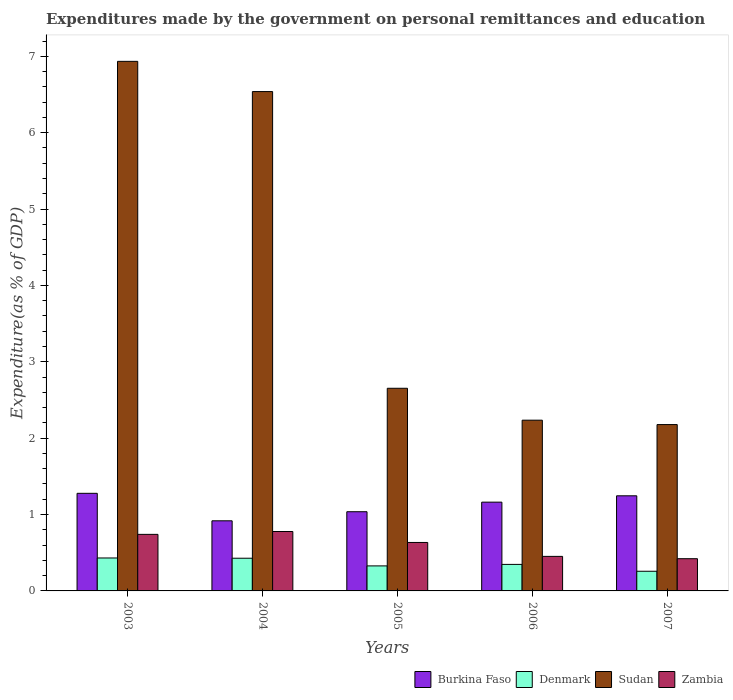How many groups of bars are there?
Your answer should be very brief. 5. What is the label of the 5th group of bars from the left?
Provide a succinct answer. 2007. In how many cases, is the number of bars for a given year not equal to the number of legend labels?
Provide a succinct answer. 0. What is the expenditures made by the government on personal remittances and education in Burkina Faso in 2005?
Give a very brief answer. 1.04. Across all years, what is the maximum expenditures made by the government on personal remittances and education in Zambia?
Ensure brevity in your answer.  0.78. Across all years, what is the minimum expenditures made by the government on personal remittances and education in Burkina Faso?
Your answer should be very brief. 0.92. What is the total expenditures made by the government on personal remittances and education in Denmark in the graph?
Your answer should be compact. 1.79. What is the difference between the expenditures made by the government on personal remittances and education in Burkina Faso in 2003 and that in 2006?
Provide a succinct answer. 0.12. What is the difference between the expenditures made by the government on personal remittances and education in Zambia in 2005 and the expenditures made by the government on personal remittances and education in Sudan in 2004?
Offer a terse response. -5.9. What is the average expenditures made by the government on personal remittances and education in Sudan per year?
Ensure brevity in your answer.  4.11. In the year 2007, what is the difference between the expenditures made by the government on personal remittances and education in Sudan and expenditures made by the government on personal remittances and education in Denmark?
Keep it short and to the point. 1.92. What is the ratio of the expenditures made by the government on personal remittances and education in Sudan in 2005 to that in 2006?
Offer a terse response. 1.19. Is the difference between the expenditures made by the government on personal remittances and education in Sudan in 2003 and 2006 greater than the difference between the expenditures made by the government on personal remittances and education in Denmark in 2003 and 2006?
Offer a very short reply. Yes. What is the difference between the highest and the second highest expenditures made by the government on personal remittances and education in Sudan?
Provide a succinct answer. 0.4. What is the difference between the highest and the lowest expenditures made by the government on personal remittances and education in Sudan?
Provide a succinct answer. 4.76. Is the sum of the expenditures made by the government on personal remittances and education in Sudan in 2005 and 2006 greater than the maximum expenditures made by the government on personal remittances and education in Zambia across all years?
Make the answer very short. Yes. What does the 3rd bar from the left in 2006 represents?
Offer a very short reply. Sudan. What does the 4th bar from the right in 2003 represents?
Offer a terse response. Burkina Faso. Is it the case that in every year, the sum of the expenditures made by the government on personal remittances and education in Denmark and expenditures made by the government on personal remittances and education in Sudan is greater than the expenditures made by the government on personal remittances and education in Zambia?
Offer a very short reply. Yes. Are all the bars in the graph horizontal?
Your answer should be compact. No. How many years are there in the graph?
Make the answer very short. 5. Are the values on the major ticks of Y-axis written in scientific E-notation?
Ensure brevity in your answer.  No. Where does the legend appear in the graph?
Your answer should be compact. Bottom right. How many legend labels are there?
Offer a terse response. 4. How are the legend labels stacked?
Ensure brevity in your answer.  Horizontal. What is the title of the graph?
Provide a succinct answer. Expenditures made by the government on personal remittances and education. What is the label or title of the Y-axis?
Offer a very short reply. Expenditure(as % of GDP). What is the Expenditure(as % of GDP) of Burkina Faso in 2003?
Your answer should be very brief. 1.28. What is the Expenditure(as % of GDP) of Denmark in 2003?
Ensure brevity in your answer.  0.43. What is the Expenditure(as % of GDP) of Sudan in 2003?
Give a very brief answer. 6.93. What is the Expenditure(as % of GDP) in Zambia in 2003?
Make the answer very short. 0.74. What is the Expenditure(as % of GDP) in Burkina Faso in 2004?
Offer a terse response. 0.92. What is the Expenditure(as % of GDP) of Denmark in 2004?
Keep it short and to the point. 0.43. What is the Expenditure(as % of GDP) in Sudan in 2004?
Provide a short and direct response. 6.54. What is the Expenditure(as % of GDP) in Zambia in 2004?
Offer a very short reply. 0.78. What is the Expenditure(as % of GDP) of Burkina Faso in 2005?
Provide a succinct answer. 1.04. What is the Expenditure(as % of GDP) in Denmark in 2005?
Give a very brief answer. 0.33. What is the Expenditure(as % of GDP) of Sudan in 2005?
Your answer should be very brief. 2.65. What is the Expenditure(as % of GDP) of Zambia in 2005?
Give a very brief answer. 0.63. What is the Expenditure(as % of GDP) in Burkina Faso in 2006?
Offer a very short reply. 1.16. What is the Expenditure(as % of GDP) in Denmark in 2006?
Your answer should be very brief. 0.35. What is the Expenditure(as % of GDP) in Sudan in 2006?
Your answer should be compact. 2.24. What is the Expenditure(as % of GDP) in Zambia in 2006?
Provide a succinct answer. 0.45. What is the Expenditure(as % of GDP) of Burkina Faso in 2007?
Your response must be concise. 1.25. What is the Expenditure(as % of GDP) in Denmark in 2007?
Offer a terse response. 0.26. What is the Expenditure(as % of GDP) in Sudan in 2007?
Give a very brief answer. 2.18. What is the Expenditure(as % of GDP) of Zambia in 2007?
Keep it short and to the point. 0.42. Across all years, what is the maximum Expenditure(as % of GDP) in Burkina Faso?
Give a very brief answer. 1.28. Across all years, what is the maximum Expenditure(as % of GDP) in Denmark?
Provide a short and direct response. 0.43. Across all years, what is the maximum Expenditure(as % of GDP) of Sudan?
Your answer should be very brief. 6.93. Across all years, what is the maximum Expenditure(as % of GDP) of Zambia?
Your response must be concise. 0.78. Across all years, what is the minimum Expenditure(as % of GDP) in Burkina Faso?
Ensure brevity in your answer.  0.92. Across all years, what is the minimum Expenditure(as % of GDP) in Denmark?
Offer a terse response. 0.26. Across all years, what is the minimum Expenditure(as % of GDP) in Sudan?
Offer a terse response. 2.18. Across all years, what is the minimum Expenditure(as % of GDP) in Zambia?
Your response must be concise. 0.42. What is the total Expenditure(as % of GDP) of Burkina Faso in the graph?
Provide a short and direct response. 5.64. What is the total Expenditure(as % of GDP) in Denmark in the graph?
Give a very brief answer. 1.79. What is the total Expenditure(as % of GDP) of Sudan in the graph?
Make the answer very short. 20.54. What is the total Expenditure(as % of GDP) of Zambia in the graph?
Make the answer very short. 3.03. What is the difference between the Expenditure(as % of GDP) in Burkina Faso in 2003 and that in 2004?
Offer a terse response. 0.36. What is the difference between the Expenditure(as % of GDP) of Denmark in 2003 and that in 2004?
Provide a succinct answer. 0. What is the difference between the Expenditure(as % of GDP) in Sudan in 2003 and that in 2004?
Ensure brevity in your answer.  0.4. What is the difference between the Expenditure(as % of GDP) of Zambia in 2003 and that in 2004?
Your response must be concise. -0.04. What is the difference between the Expenditure(as % of GDP) of Burkina Faso in 2003 and that in 2005?
Offer a very short reply. 0.24. What is the difference between the Expenditure(as % of GDP) of Denmark in 2003 and that in 2005?
Ensure brevity in your answer.  0.1. What is the difference between the Expenditure(as % of GDP) of Sudan in 2003 and that in 2005?
Your response must be concise. 4.28. What is the difference between the Expenditure(as % of GDP) in Zambia in 2003 and that in 2005?
Make the answer very short. 0.11. What is the difference between the Expenditure(as % of GDP) of Burkina Faso in 2003 and that in 2006?
Give a very brief answer. 0.12. What is the difference between the Expenditure(as % of GDP) in Denmark in 2003 and that in 2006?
Your response must be concise. 0.08. What is the difference between the Expenditure(as % of GDP) of Sudan in 2003 and that in 2006?
Your response must be concise. 4.7. What is the difference between the Expenditure(as % of GDP) of Zambia in 2003 and that in 2006?
Provide a short and direct response. 0.29. What is the difference between the Expenditure(as % of GDP) of Burkina Faso in 2003 and that in 2007?
Your answer should be very brief. 0.03. What is the difference between the Expenditure(as % of GDP) in Denmark in 2003 and that in 2007?
Offer a very short reply. 0.17. What is the difference between the Expenditure(as % of GDP) in Sudan in 2003 and that in 2007?
Your answer should be very brief. 4.76. What is the difference between the Expenditure(as % of GDP) in Zambia in 2003 and that in 2007?
Provide a short and direct response. 0.32. What is the difference between the Expenditure(as % of GDP) in Burkina Faso in 2004 and that in 2005?
Ensure brevity in your answer.  -0.12. What is the difference between the Expenditure(as % of GDP) in Denmark in 2004 and that in 2005?
Provide a short and direct response. 0.1. What is the difference between the Expenditure(as % of GDP) of Sudan in 2004 and that in 2005?
Your answer should be compact. 3.88. What is the difference between the Expenditure(as % of GDP) of Zambia in 2004 and that in 2005?
Provide a succinct answer. 0.14. What is the difference between the Expenditure(as % of GDP) in Burkina Faso in 2004 and that in 2006?
Your response must be concise. -0.24. What is the difference between the Expenditure(as % of GDP) of Denmark in 2004 and that in 2006?
Your answer should be compact. 0.08. What is the difference between the Expenditure(as % of GDP) in Sudan in 2004 and that in 2006?
Keep it short and to the point. 4.3. What is the difference between the Expenditure(as % of GDP) in Zambia in 2004 and that in 2006?
Your answer should be compact. 0.33. What is the difference between the Expenditure(as % of GDP) of Burkina Faso in 2004 and that in 2007?
Offer a terse response. -0.33. What is the difference between the Expenditure(as % of GDP) in Denmark in 2004 and that in 2007?
Your answer should be very brief. 0.17. What is the difference between the Expenditure(as % of GDP) in Sudan in 2004 and that in 2007?
Offer a terse response. 4.36. What is the difference between the Expenditure(as % of GDP) of Zambia in 2004 and that in 2007?
Give a very brief answer. 0.36. What is the difference between the Expenditure(as % of GDP) of Burkina Faso in 2005 and that in 2006?
Your answer should be compact. -0.13. What is the difference between the Expenditure(as % of GDP) in Denmark in 2005 and that in 2006?
Offer a very short reply. -0.02. What is the difference between the Expenditure(as % of GDP) of Sudan in 2005 and that in 2006?
Give a very brief answer. 0.42. What is the difference between the Expenditure(as % of GDP) of Zambia in 2005 and that in 2006?
Offer a terse response. 0.18. What is the difference between the Expenditure(as % of GDP) of Burkina Faso in 2005 and that in 2007?
Offer a very short reply. -0.21. What is the difference between the Expenditure(as % of GDP) of Denmark in 2005 and that in 2007?
Your answer should be very brief. 0.07. What is the difference between the Expenditure(as % of GDP) in Sudan in 2005 and that in 2007?
Your answer should be very brief. 0.48. What is the difference between the Expenditure(as % of GDP) of Zambia in 2005 and that in 2007?
Provide a succinct answer. 0.21. What is the difference between the Expenditure(as % of GDP) in Burkina Faso in 2006 and that in 2007?
Your response must be concise. -0.08. What is the difference between the Expenditure(as % of GDP) of Denmark in 2006 and that in 2007?
Give a very brief answer. 0.09. What is the difference between the Expenditure(as % of GDP) of Sudan in 2006 and that in 2007?
Offer a very short reply. 0.06. What is the difference between the Expenditure(as % of GDP) of Zambia in 2006 and that in 2007?
Ensure brevity in your answer.  0.03. What is the difference between the Expenditure(as % of GDP) of Burkina Faso in 2003 and the Expenditure(as % of GDP) of Denmark in 2004?
Offer a very short reply. 0.85. What is the difference between the Expenditure(as % of GDP) of Burkina Faso in 2003 and the Expenditure(as % of GDP) of Sudan in 2004?
Provide a succinct answer. -5.26. What is the difference between the Expenditure(as % of GDP) in Denmark in 2003 and the Expenditure(as % of GDP) in Sudan in 2004?
Make the answer very short. -6.11. What is the difference between the Expenditure(as % of GDP) in Denmark in 2003 and the Expenditure(as % of GDP) in Zambia in 2004?
Give a very brief answer. -0.35. What is the difference between the Expenditure(as % of GDP) of Sudan in 2003 and the Expenditure(as % of GDP) of Zambia in 2004?
Give a very brief answer. 6.16. What is the difference between the Expenditure(as % of GDP) in Burkina Faso in 2003 and the Expenditure(as % of GDP) in Denmark in 2005?
Your answer should be very brief. 0.95. What is the difference between the Expenditure(as % of GDP) of Burkina Faso in 2003 and the Expenditure(as % of GDP) of Sudan in 2005?
Your response must be concise. -1.38. What is the difference between the Expenditure(as % of GDP) of Burkina Faso in 2003 and the Expenditure(as % of GDP) of Zambia in 2005?
Your answer should be very brief. 0.64. What is the difference between the Expenditure(as % of GDP) in Denmark in 2003 and the Expenditure(as % of GDP) in Sudan in 2005?
Make the answer very short. -2.22. What is the difference between the Expenditure(as % of GDP) of Denmark in 2003 and the Expenditure(as % of GDP) of Zambia in 2005?
Provide a succinct answer. -0.2. What is the difference between the Expenditure(as % of GDP) of Sudan in 2003 and the Expenditure(as % of GDP) of Zambia in 2005?
Your response must be concise. 6.3. What is the difference between the Expenditure(as % of GDP) of Burkina Faso in 2003 and the Expenditure(as % of GDP) of Denmark in 2006?
Offer a terse response. 0.93. What is the difference between the Expenditure(as % of GDP) in Burkina Faso in 2003 and the Expenditure(as % of GDP) in Sudan in 2006?
Give a very brief answer. -0.96. What is the difference between the Expenditure(as % of GDP) of Burkina Faso in 2003 and the Expenditure(as % of GDP) of Zambia in 2006?
Make the answer very short. 0.83. What is the difference between the Expenditure(as % of GDP) of Denmark in 2003 and the Expenditure(as % of GDP) of Sudan in 2006?
Provide a succinct answer. -1.8. What is the difference between the Expenditure(as % of GDP) in Denmark in 2003 and the Expenditure(as % of GDP) in Zambia in 2006?
Make the answer very short. -0.02. What is the difference between the Expenditure(as % of GDP) in Sudan in 2003 and the Expenditure(as % of GDP) in Zambia in 2006?
Keep it short and to the point. 6.48. What is the difference between the Expenditure(as % of GDP) in Burkina Faso in 2003 and the Expenditure(as % of GDP) in Denmark in 2007?
Ensure brevity in your answer.  1.02. What is the difference between the Expenditure(as % of GDP) of Burkina Faso in 2003 and the Expenditure(as % of GDP) of Sudan in 2007?
Provide a succinct answer. -0.9. What is the difference between the Expenditure(as % of GDP) of Burkina Faso in 2003 and the Expenditure(as % of GDP) of Zambia in 2007?
Offer a very short reply. 0.86. What is the difference between the Expenditure(as % of GDP) in Denmark in 2003 and the Expenditure(as % of GDP) in Sudan in 2007?
Provide a succinct answer. -1.75. What is the difference between the Expenditure(as % of GDP) in Denmark in 2003 and the Expenditure(as % of GDP) in Zambia in 2007?
Offer a very short reply. 0.01. What is the difference between the Expenditure(as % of GDP) of Sudan in 2003 and the Expenditure(as % of GDP) of Zambia in 2007?
Give a very brief answer. 6.51. What is the difference between the Expenditure(as % of GDP) of Burkina Faso in 2004 and the Expenditure(as % of GDP) of Denmark in 2005?
Make the answer very short. 0.59. What is the difference between the Expenditure(as % of GDP) of Burkina Faso in 2004 and the Expenditure(as % of GDP) of Sudan in 2005?
Your answer should be compact. -1.74. What is the difference between the Expenditure(as % of GDP) of Burkina Faso in 2004 and the Expenditure(as % of GDP) of Zambia in 2005?
Make the answer very short. 0.28. What is the difference between the Expenditure(as % of GDP) of Denmark in 2004 and the Expenditure(as % of GDP) of Sudan in 2005?
Provide a succinct answer. -2.23. What is the difference between the Expenditure(as % of GDP) in Denmark in 2004 and the Expenditure(as % of GDP) in Zambia in 2005?
Give a very brief answer. -0.21. What is the difference between the Expenditure(as % of GDP) of Sudan in 2004 and the Expenditure(as % of GDP) of Zambia in 2005?
Offer a very short reply. 5.9. What is the difference between the Expenditure(as % of GDP) of Burkina Faso in 2004 and the Expenditure(as % of GDP) of Denmark in 2006?
Ensure brevity in your answer.  0.57. What is the difference between the Expenditure(as % of GDP) in Burkina Faso in 2004 and the Expenditure(as % of GDP) in Sudan in 2006?
Your answer should be very brief. -1.32. What is the difference between the Expenditure(as % of GDP) in Burkina Faso in 2004 and the Expenditure(as % of GDP) in Zambia in 2006?
Ensure brevity in your answer.  0.47. What is the difference between the Expenditure(as % of GDP) of Denmark in 2004 and the Expenditure(as % of GDP) of Sudan in 2006?
Your answer should be very brief. -1.81. What is the difference between the Expenditure(as % of GDP) of Denmark in 2004 and the Expenditure(as % of GDP) of Zambia in 2006?
Your answer should be very brief. -0.02. What is the difference between the Expenditure(as % of GDP) of Sudan in 2004 and the Expenditure(as % of GDP) of Zambia in 2006?
Your answer should be very brief. 6.09. What is the difference between the Expenditure(as % of GDP) of Burkina Faso in 2004 and the Expenditure(as % of GDP) of Denmark in 2007?
Give a very brief answer. 0.66. What is the difference between the Expenditure(as % of GDP) in Burkina Faso in 2004 and the Expenditure(as % of GDP) in Sudan in 2007?
Offer a very short reply. -1.26. What is the difference between the Expenditure(as % of GDP) in Burkina Faso in 2004 and the Expenditure(as % of GDP) in Zambia in 2007?
Keep it short and to the point. 0.5. What is the difference between the Expenditure(as % of GDP) in Denmark in 2004 and the Expenditure(as % of GDP) in Sudan in 2007?
Make the answer very short. -1.75. What is the difference between the Expenditure(as % of GDP) in Denmark in 2004 and the Expenditure(as % of GDP) in Zambia in 2007?
Make the answer very short. 0.01. What is the difference between the Expenditure(as % of GDP) in Sudan in 2004 and the Expenditure(as % of GDP) in Zambia in 2007?
Your answer should be compact. 6.12. What is the difference between the Expenditure(as % of GDP) in Burkina Faso in 2005 and the Expenditure(as % of GDP) in Denmark in 2006?
Offer a terse response. 0.69. What is the difference between the Expenditure(as % of GDP) in Burkina Faso in 2005 and the Expenditure(as % of GDP) in Sudan in 2006?
Offer a very short reply. -1.2. What is the difference between the Expenditure(as % of GDP) of Burkina Faso in 2005 and the Expenditure(as % of GDP) of Zambia in 2006?
Your answer should be very brief. 0.58. What is the difference between the Expenditure(as % of GDP) in Denmark in 2005 and the Expenditure(as % of GDP) in Sudan in 2006?
Your answer should be very brief. -1.91. What is the difference between the Expenditure(as % of GDP) of Denmark in 2005 and the Expenditure(as % of GDP) of Zambia in 2006?
Give a very brief answer. -0.12. What is the difference between the Expenditure(as % of GDP) of Sudan in 2005 and the Expenditure(as % of GDP) of Zambia in 2006?
Your response must be concise. 2.2. What is the difference between the Expenditure(as % of GDP) in Burkina Faso in 2005 and the Expenditure(as % of GDP) in Denmark in 2007?
Offer a very short reply. 0.78. What is the difference between the Expenditure(as % of GDP) in Burkina Faso in 2005 and the Expenditure(as % of GDP) in Sudan in 2007?
Offer a terse response. -1.14. What is the difference between the Expenditure(as % of GDP) in Burkina Faso in 2005 and the Expenditure(as % of GDP) in Zambia in 2007?
Your answer should be very brief. 0.61. What is the difference between the Expenditure(as % of GDP) of Denmark in 2005 and the Expenditure(as % of GDP) of Sudan in 2007?
Provide a succinct answer. -1.85. What is the difference between the Expenditure(as % of GDP) of Denmark in 2005 and the Expenditure(as % of GDP) of Zambia in 2007?
Your answer should be compact. -0.09. What is the difference between the Expenditure(as % of GDP) of Sudan in 2005 and the Expenditure(as % of GDP) of Zambia in 2007?
Make the answer very short. 2.23. What is the difference between the Expenditure(as % of GDP) of Burkina Faso in 2006 and the Expenditure(as % of GDP) of Denmark in 2007?
Keep it short and to the point. 0.9. What is the difference between the Expenditure(as % of GDP) in Burkina Faso in 2006 and the Expenditure(as % of GDP) in Sudan in 2007?
Your answer should be very brief. -1.02. What is the difference between the Expenditure(as % of GDP) in Burkina Faso in 2006 and the Expenditure(as % of GDP) in Zambia in 2007?
Keep it short and to the point. 0.74. What is the difference between the Expenditure(as % of GDP) in Denmark in 2006 and the Expenditure(as % of GDP) in Sudan in 2007?
Make the answer very short. -1.83. What is the difference between the Expenditure(as % of GDP) in Denmark in 2006 and the Expenditure(as % of GDP) in Zambia in 2007?
Your response must be concise. -0.07. What is the difference between the Expenditure(as % of GDP) of Sudan in 2006 and the Expenditure(as % of GDP) of Zambia in 2007?
Provide a succinct answer. 1.81. What is the average Expenditure(as % of GDP) in Burkina Faso per year?
Your response must be concise. 1.13. What is the average Expenditure(as % of GDP) of Denmark per year?
Give a very brief answer. 0.36. What is the average Expenditure(as % of GDP) of Sudan per year?
Offer a terse response. 4.11. What is the average Expenditure(as % of GDP) in Zambia per year?
Your response must be concise. 0.61. In the year 2003, what is the difference between the Expenditure(as % of GDP) in Burkina Faso and Expenditure(as % of GDP) in Denmark?
Offer a terse response. 0.85. In the year 2003, what is the difference between the Expenditure(as % of GDP) in Burkina Faso and Expenditure(as % of GDP) in Sudan?
Provide a short and direct response. -5.66. In the year 2003, what is the difference between the Expenditure(as % of GDP) in Burkina Faso and Expenditure(as % of GDP) in Zambia?
Offer a terse response. 0.54. In the year 2003, what is the difference between the Expenditure(as % of GDP) of Denmark and Expenditure(as % of GDP) of Sudan?
Provide a succinct answer. -6.5. In the year 2003, what is the difference between the Expenditure(as % of GDP) in Denmark and Expenditure(as % of GDP) in Zambia?
Ensure brevity in your answer.  -0.31. In the year 2003, what is the difference between the Expenditure(as % of GDP) in Sudan and Expenditure(as % of GDP) in Zambia?
Your response must be concise. 6.19. In the year 2004, what is the difference between the Expenditure(as % of GDP) in Burkina Faso and Expenditure(as % of GDP) in Denmark?
Your response must be concise. 0.49. In the year 2004, what is the difference between the Expenditure(as % of GDP) of Burkina Faso and Expenditure(as % of GDP) of Sudan?
Your answer should be very brief. -5.62. In the year 2004, what is the difference between the Expenditure(as % of GDP) in Burkina Faso and Expenditure(as % of GDP) in Zambia?
Make the answer very short. 0.14. In the year 2004, what is the difference between the Expenditure(as % of GDP) in Denmark and Expenditure(as % of GDP) in Sudan?
Your answer should be very brief. -6.11. In the year 2004, what is the difference between the Expenditure(as % of GDP) in Denmark and Expenditure(as % of GDP) in Zambia?
Offer a very short reply. -0.35. In the year 2004, what is the difference between the Expenditure(as % of GDP) of Sudan and Expenditure(as % of GDP) of Zambia?
Your answer should be compact. 5.76. In the year 2005, what is the difference between the Expenditure(as % of GDP) in Burkina Faso and Expenditure(as % of GDP) in Denmark?
Ensure brevity in your answer.  0.71. In the year 2005, what is the difference between the Expenditure(as % of GDP) of Burkina Faso and Expenditure(as % of GDP) of Sudan?
Your response must be concise. -1.62. In the year 2005, what is the difference between the Expenditure(as % of GDP) in Burkina Faso and Expenditure(as % of GDP) in Zambia?
Offer a terse response. 0.4. In the year 2005, what is the difference between the Expenditure(as % of GDP) of Denmark and Expenditure(as % of GDP) of Sudan?
Your response must be concise. -2.33. In the year 2005, what is the difference between the Expenditure(as % of GDP) in Denmark and Expenditure(as % of GDP) in Zambia?
Offer a very short reply. -0.31. In the year 2005, what is the difference between the Expenditure(as % of GDP) of Sudan and Expenditure(as % of GDP) of Zambia?
Keep it short and to the point. 2.02. In the year 2006, what is the difference between the Expenditure(as % of GDP) in Burkina Faso and Expenditure(as % of GDP) in Denmark?
Ensure brevity in your answer.  0.82. In the year 2006, what is the difference between the Expenditure(as % of GDP) of Burkina Faso and Expenditure(as % of GDP) of Sudan?
Offer a terse response. -1.07. In the year 2006, what is the difference between the Expenditure(as % of GDP) in Burkina Faso and Expenditure(as % of GDP) in Zambia?
Give a very brief answer. 0.71. In the year 2006, what is the difference between the Expenditure(as % of GDP) in Denmark and Expenditure(as % of GDP) in Sudan?
Keep it short and to the point. -1.89. In the year 2006, what is the difference between the Expenditure(as % of GDP) in Denmark and Expenditure(as % of GDP) in Zambia?
Offer a very short reply. -0.1. In the year 2006, what is the difference between the Expenditure(as % of GDP) of Sudan and Expenditure(as % of GDP) of Zambia?
Your answer should be compact. 1.78. In the year 2007, what is the difference between the Expenditure(as % of GDP) of Burkina Faso and Expenditure(as % of GDP) of Sudan?
Your answer should be compact. -0.93. In the year 2007, what is the difference between the Expenditure(as % of GDP) in Burkina Faso and Expenditure(as % of GDP) in Zambia?
Keep it short and to the point. 0.82. In the year 2007, what is the difference between the Expenditure(as % of GDP) in Denmark and Expenditure(as % of GDP) in Sudan?
Make the answer very short. -1.92. In the year 2007, what is the difference between the Expenditure(as % of GDP) in Denmark and Expenditure(as % of GDP) in Zambia?
Your response must be concise. -0.16. In the year 2007, what is the difference between the Expenditure(as % of GDP) in Sudan and Expenditure(as % of GDP) in Zambia?
Offer a terse response. 1.76. What is the ratio of the Expenditure(as % of GDP) of Burkina Faso in 2003 to that in 2004?
Provide a short and direct response. 1.39. What is the ratio of the Expenditure(as % of GDP) in Denmark in 2003 to that in 2004?
Your answer should be compact. 1.01. What is the ratio of the Expenditure(as % of GDP) in Sudan in 2003 to that in 2004?
Your response must be concise. 1.06. What is the ratio of the Expenditure(as % of GDP) of Zambia in 2003 to that in 2004?
Your response must be concise. 0.95. What is the ratio of the Expenditure(as % of GDP) of Burkina Faso in 2003 to that in 2005?
Offer a terse response. 1.23. What is the ratio of the Expenditure(as % of GDP) of Denmark in 2003 to that in 2005?
Make the answer very short. 1.32. What is the ratio of the Expenditure(as % of GDP) in Sudan in 2003 to that in 2005?
Your answer should be very brief. 2.61. What is the ratio of the Expenditure(as % of GDP) in Zambia in 2003 to that in 2005?
Provide a short and direct response. 1.17. What is the ratio of the Expenditure(as % of GDP) of Burkina Faso in 2003 to that in 2006?
Offer a terse response. 1.1. What is the ratio of the Expenditure(as % of GDP) of Denmark in 2003 to that in 2006?
Keep it short and to the point. 1.24. What is the ratio of the Expenditure(as % of GDP) of Sudan in 2003 to that in 2006?
Offer a terse response. 3.1. What is the ratio of the Expenditure(as % of GDP) in Zambia in 2003 to that in 2006?
Give a very brief answer. 1.64. What is the ratio of the Expenditure(as % of GDP) in Burkina Faso in 2003 to that in 2007?
Your answer should be compact. 1.03. What is the ratio of the Expenditure(as % of GDP) of Denmark in 2003 to that in 2007?
Your response must be concise. 1.67. What is the ratio of the Expenditure(as % of GDP) in Sudan in 2003 to that in 2007?
Offer a very short reply. 3.18. What is the ratio of the Expenditure(as % of GDP) of Zambia in 2003 to that in 2007?
Ensure brevity in your answer.  1.76. What is the ratio of the Expenditure(as % of GDP) of Burkina Faso in 2004 to that in 2005?
Provide a succinct answer. 0.89. What is the ratio of the Expenditure(as % of GDP) in Denmark in 2004 to that in 2005?
Your answer should be very brief. 1.31. What is the ratio of the Expenditure(as % of GDP) in Sudan in 2004 to that in 2005?
Your answer should be compact. 2.46. What is the ratio of the Expenditure(as % of GDP) of Zambia in 2004 to that in 2005?
Give a very brief answer. 1.23. What is the ratio of the Expenditure(as % of GDP) in Burkina Faso in 2004 to that in 2006?
Offer a very short reply. 0.79. What is the ratio of the Expenditure(as % of GDP) in Denmark in 2004 to that in 2006?
Provide a short and direct response. 1.23. What is the ratio of the Expenditure(as % of GDP) of Sudan in 2004 to that in 2006?
Provide a succinct answer. 2.92. What is the ratio of the Expenditure(as % of GDP) in Zambia in 2004 to that in 2006?
Provide a short and direct response. 1.72. What is the ratio of the Expenditure(as % of GDP) of Burkina Faso in 2004 to that in 2007?
Ensure brevity in your answer.  0.74. What is the ratio of the Expenditure(as % of GDP) in Denmark in 2004 to that in 2007?
Provide a short and direct response. 1.66. What is the ratio of the Expenditure(as % of GDP) in Sudan in 2004 to that in 2007?
Ensure brevity in your answer.  3. What is the ratio of the Expenditure(as % of GDP) in Zambia in 2004 to that in 2007?
Your answer should be very brief. 1.84. What is the ratio of the Expenditure(as % of GDP) of Burkina Faso in 2005 to that in 2006?
Ensure brevity in your answer.  0.89. What is the ratio of the Expenditure(as % of GDP) of Denmark in 2005 to that in 2006?
Ensure brevity in your answer.  0.94. What is the ratio of the Expenditure(as % of GDP) in Sudan in 2005 to that in 2006?
Provide a short and direct response. 1.19. What is the ratio of the Expenditure(as % of GDP) in Zambia in 2005 to that in 2006?
Your answer should be very brief. 1.4. What is the ratio of the Expenditure(as % of GDP) of Burkina Faso in 2005 to that in 2007?
Keep it short and to the point. 0.83. What is the ratio of the Expenditure(as % of GDP) of Denmark in 2005 to that in 2007?
Make the answer very short. 1.27. What is the ratio of the Expenditure(as % of GDP) of Sudan in 2005 to that in 2007?
Provide a succinct answer. 1.22. What is the ratio of the Expenditure(as % of GDP) of Zambia in 2005 to that in 2007?
Make the answer very short. 1.5. What is the ratio of the Expenditure(as % of GDP) in Burkina Faso in 2006 to that in 2007?
Ensure brevity in your answer.  0.93. What is the ratio of the Expenditure(as % of GDP) in Denmark in 2006 to that in 2007?
Keep it short and to the point. 1.35. What is the ratio of the Expenditure(as % of GDP) of Sudan in 2006 to that in 2007?
Keep it short and to the point. 1.03. What is the ratio of the Expenditure(as % of GDP) in Zambia in 2006 to that in 2007?
Give a very brief answer. 1.07. What is the difference between the highest and the second highest Expenditure(as % of GDP) in Burkina Faso?
Ensure brevity in your answer.  0.03. What is the difference between the highest and the second highest Expenditure(as % of GDP) of Denmark?
Your answer should be very brief. 0. What is the difference between the highest and the second highest Expenditure(as % of GDP) in Sudan?
Your response must be concise. 0.4. What is the difference between the highest and the second highest Expenditure(as % of GDP) in Zambia?
Your response must be concise. 0.04. What is the difference between the highest and the lowest Expenditure(as % of GDP) of Burkina Faso?
Ensure brevity in your answer.  0.36. What is the difference between the highest and the lowest Expenditure(as % of GDP) of Denmark?
Provide a short and direct response. 0.17. What is the difference between the highest and the lowest Expenditure(as % of GDP) in Sudan?
Provide a short and direct response. 4.76. What is the difference between the highest and the lowest Expenditure(as % of GDP) in Zambia?
Offer a terse response. 0.36. 